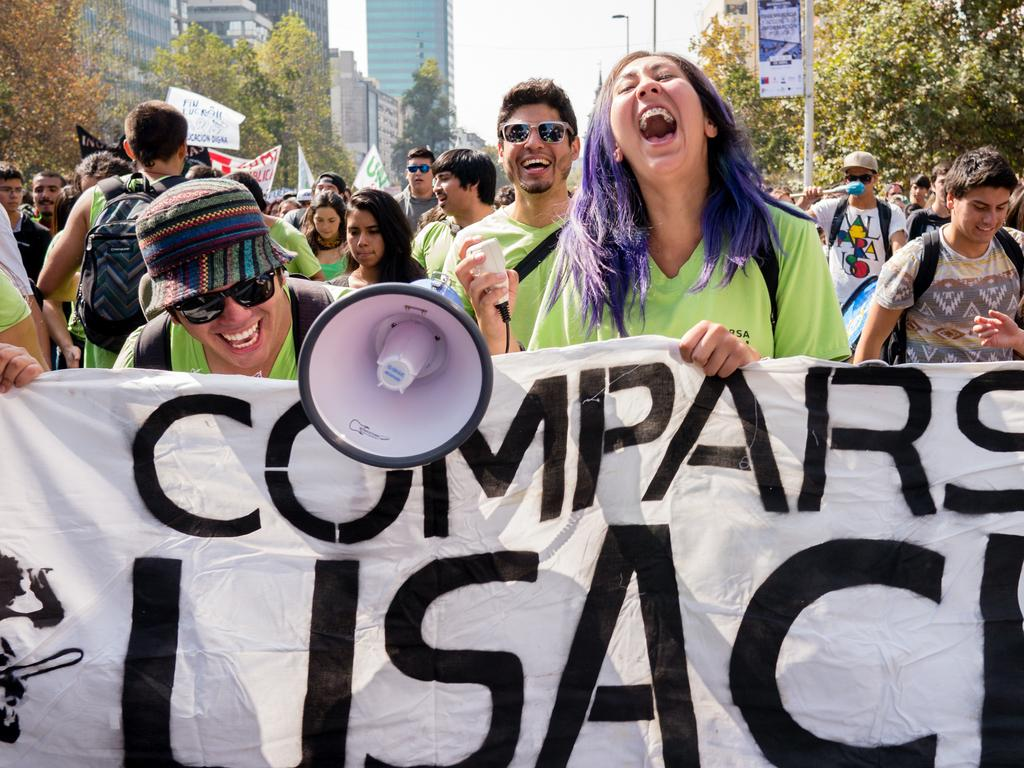What can be seen in the image? There are people, flags, a horn speaker, poles, a board, trees, buildings, and the sky visible in the image. What might the people be doing in the image? It is not clear from the image what the people are doing, but they could be participating in an event or gathering. What is the horn speaker used for? The horn speaker is likely used for amplifying sound, such as music or announcements. What type of structures are visible in the image? The buildings in the image are visible structures. What can be seen in the background of the image? The sky is visible in the background of the image. Are there any dinosaurs visible in the image? No, there are no dinosaurs present in the image. What type of committee is meeting in the image? There is no committee meeting in the image; it features people, flags, a horn speaker, poles, a board, trees, buildings, and the sky. 